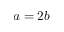<formula> <loc_0><loc_0><loc_500><loc_500>a = 2 b</formula> 